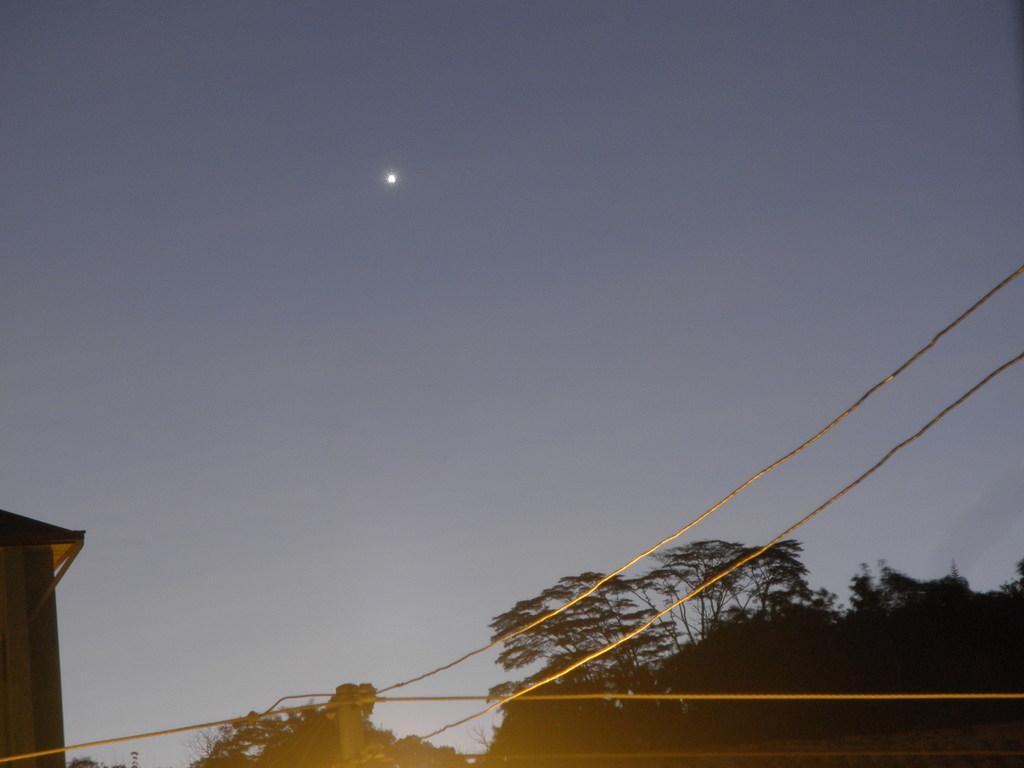Please provide a concise description of this image. In this image we can see trees, ropes and other objects. At the top of the image there is the sky and moon. 